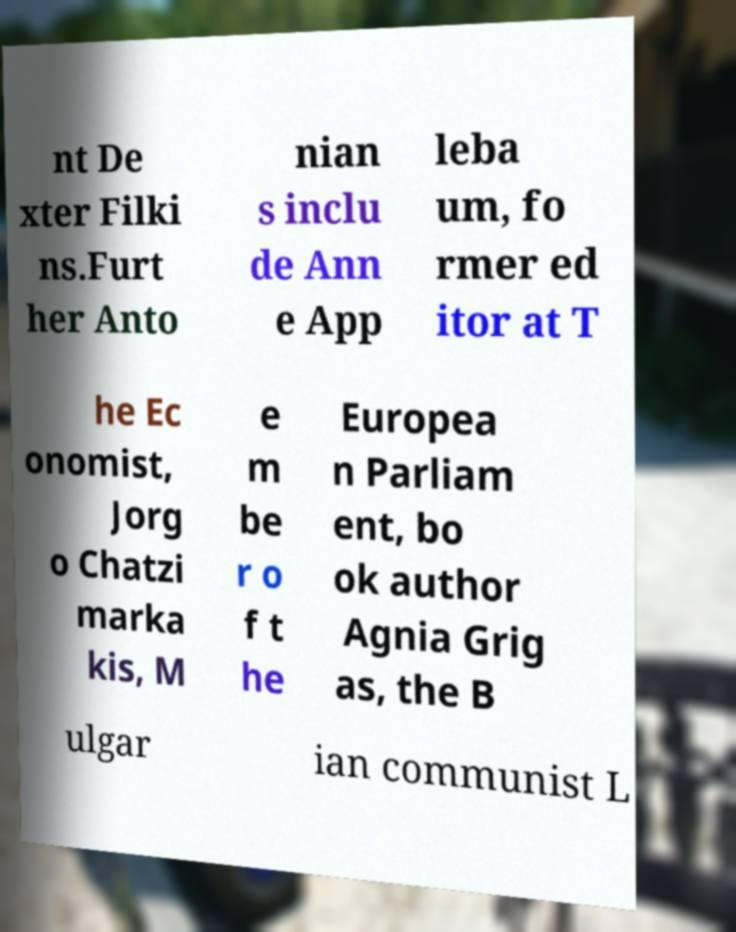Please identify and transcribe the text found in this image. nt De xter Filki ns.Furt her Anto nian s inclu de Ann e App leba um, fo rmer ed itor at T he Ec onomist, Jorg o Chatzi marka kis, M e m be r o f t he Europea n Parliam ent, bo ok author Agnia Grig as, the B ulgar ian communist L 